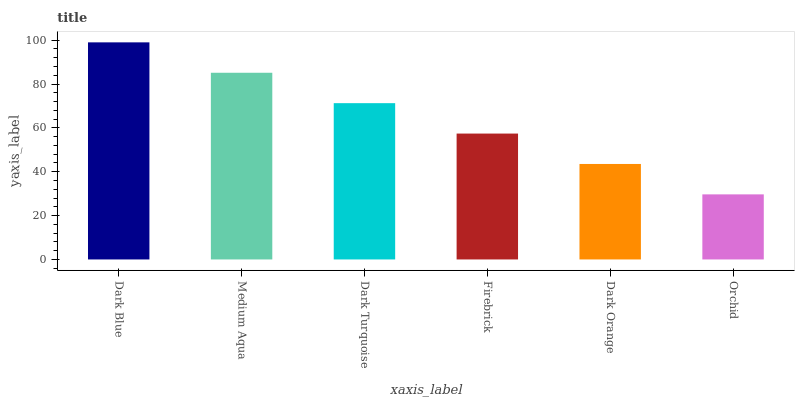Is Orchid the minimum?
Answer yes or no. Yes. Is Dark Blue the maximum?
Answer yes or no. Yes. Is Medium Aqua the minimum?
Answer yes or no. No. Is Medium Aqua the maximum?
Answer yes or no. No. Is Dark Blue greater than Medium Aqua?
Answer yes or no. Yes. Is Medium Aqua less than Dark Blue?
Answer yes or no. Yes. Is Medium Aqua greater than Dark Blue?
Answer yes or no. No. Is Dark Blue less than Medium Aqua?
Answer yes or no. No. Is Dark Turquoise the high median?
Answer yes or no. Yes. Is Firebrick the low median?
Answer yes or no. Yes. Is Dark Blue the high median?
Answer yes or no. No. Is Orchid the low median?
Answer yes or no. No. 